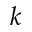Convert formula to latex. <formula><loc_0><loc_0><loc_500><loc_500>k</formula> 